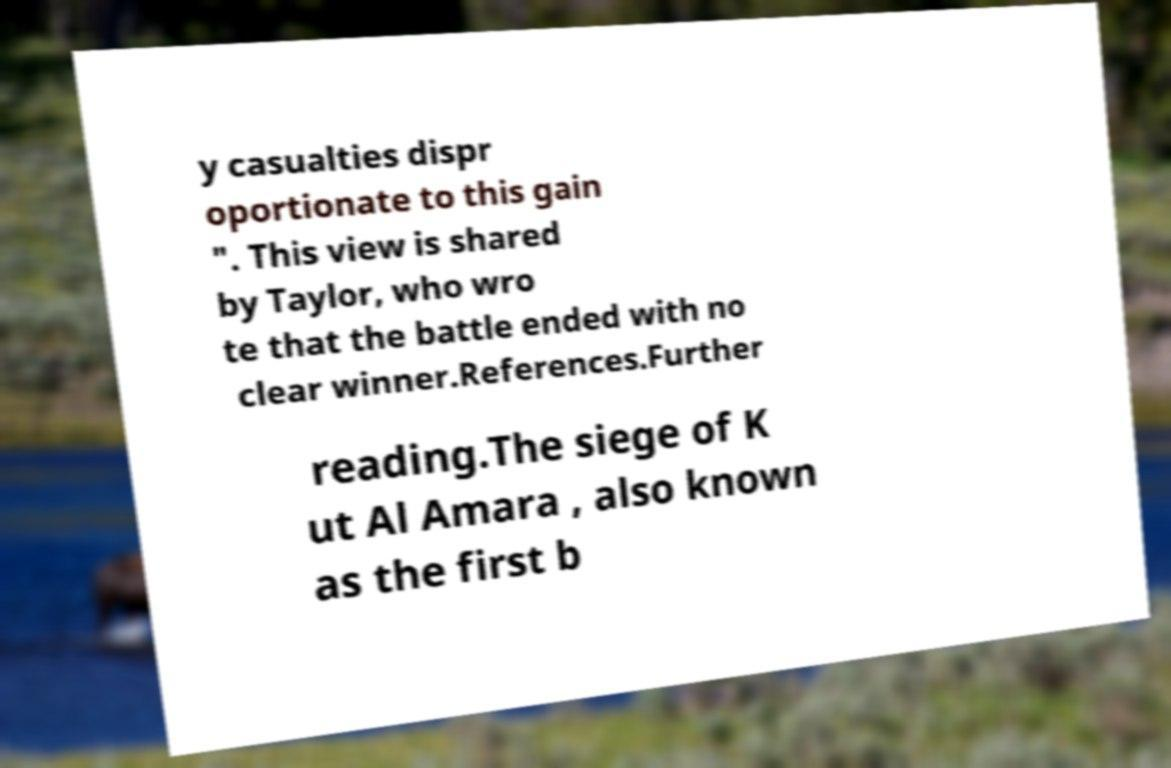I need the written content from this picture converted into text. Can you do that? y casualties dispr oportionate to this gain ". This view is shared by Taylor, who wro te that the battle ended with no clear winner.References.Further reading.The siege of K ut Al Amara , also known as the first b 